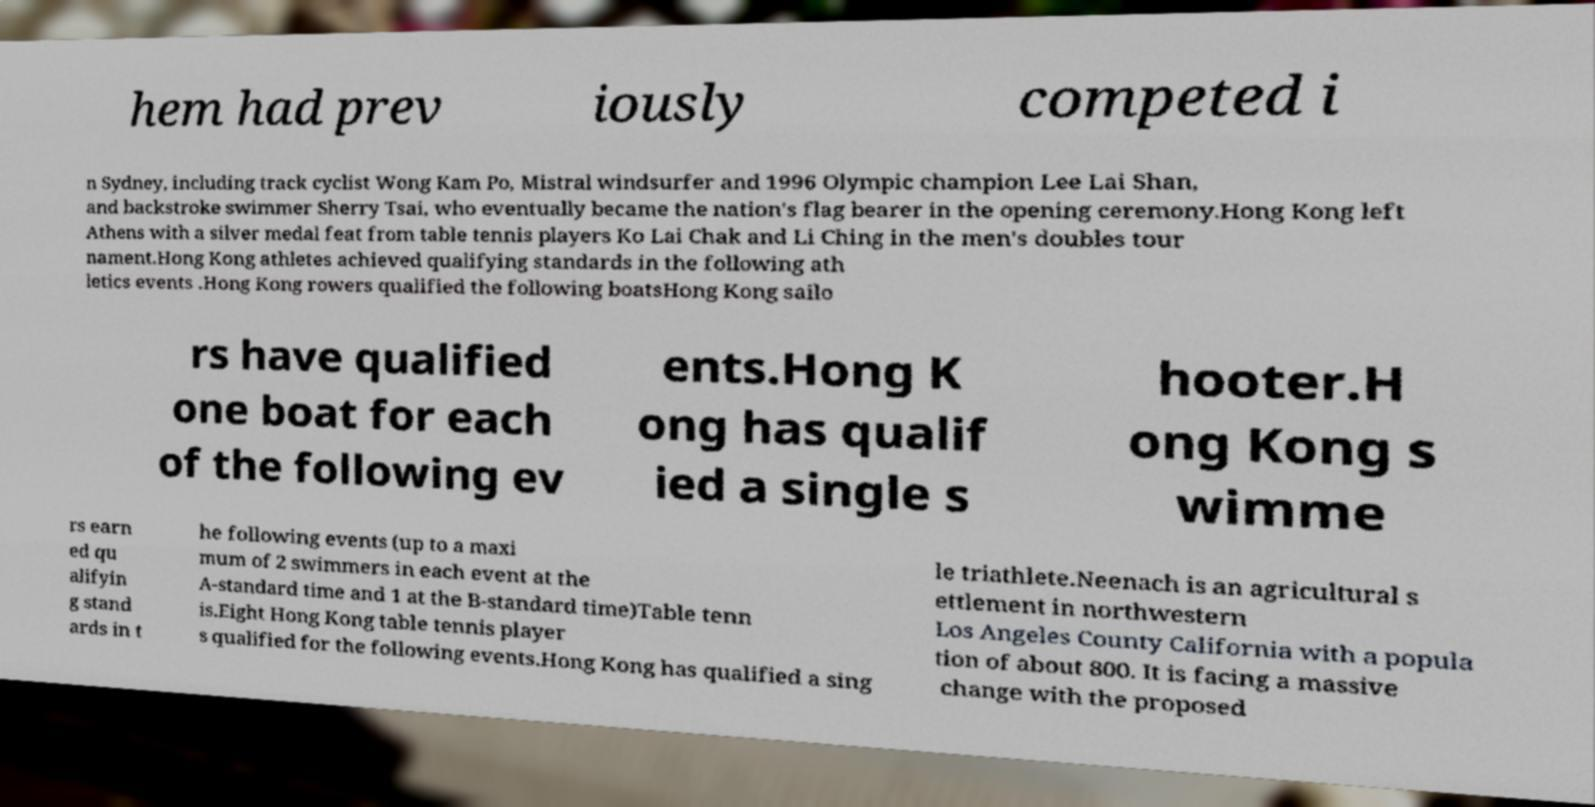Can you read and provide the text displayed in the image?This photo seems to have some interesting text. Can you extract and type it out for me? hem had prev iously competed i n Sydney, including track cyclist Wong Kam Po, Mistral windsurfer and 1996 Olympic champion Lee Lai Shan, and backstroke swimmer Sherry Tsai, who eventually became the nation's flag bearer in the opening ceremony.Hong Kong left Athens with a silver medal feat from table tennis players Ko Lai Chak and Li Ching in the men's doubles tour nament.Hong Kong athletes achieved qualifying standards in the following ath letics events .Hong Kong rowers qualified the following boatsHong Kong sailo rs have qualified one boat for each of the following ev ents.Hong K ong has qualif ied a single s hooter.H ong Kong s wimme rs earn ed qu alifyin g stand ards in t he following events (up to a maxi mum of 2 swimmers in each event at the A-standard time and 1 at the B-standard time)Table tenn is.Eight Hong Kong table tennis player s qualified for the following events.Hong Kong has qualified a sing le triathlete.Neenach is an agricultural s ettlement in northwestern Los Angeles County California with a popula tion of about 800. It is facing a massive change with the proposed 